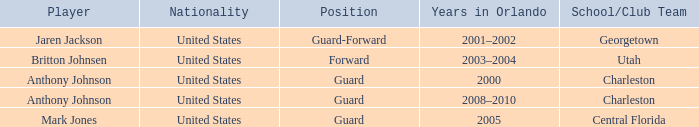Who was the Player that spent the Year 2005 in Orlando? Mark Jones. 